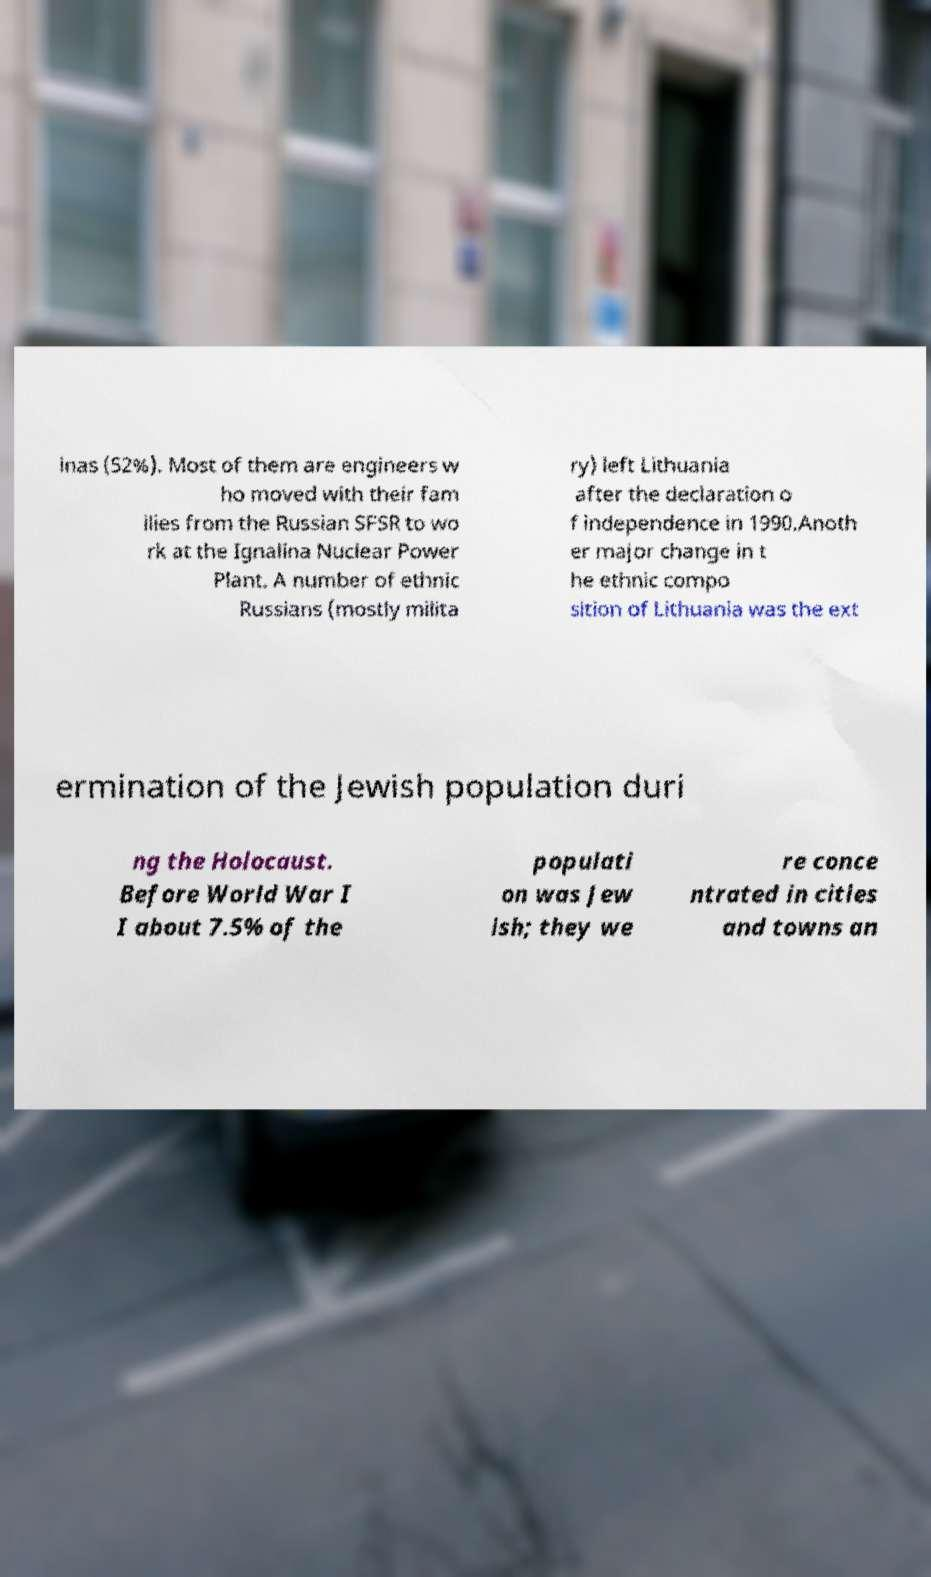Could you assist in decoding the text presented in this image and type it out clearly? inas (52%). Most of them are engineers w ho moved with their fam ilies from the Russian SFSR to wo rk at the Ignalina Nuclear Power Plant. A number of ethnic Russians (mostly milita ry) left Lithuania after the declaration o f independence in 1990.Anoth er major change in t he ethnic compo sition of Lithuania was the ext ermination of the Jewish population duri ng the Holocaust. Before World War I I about 7.5% of the populati on was Jew ish; they we re conce ntrated in cities and towns an 